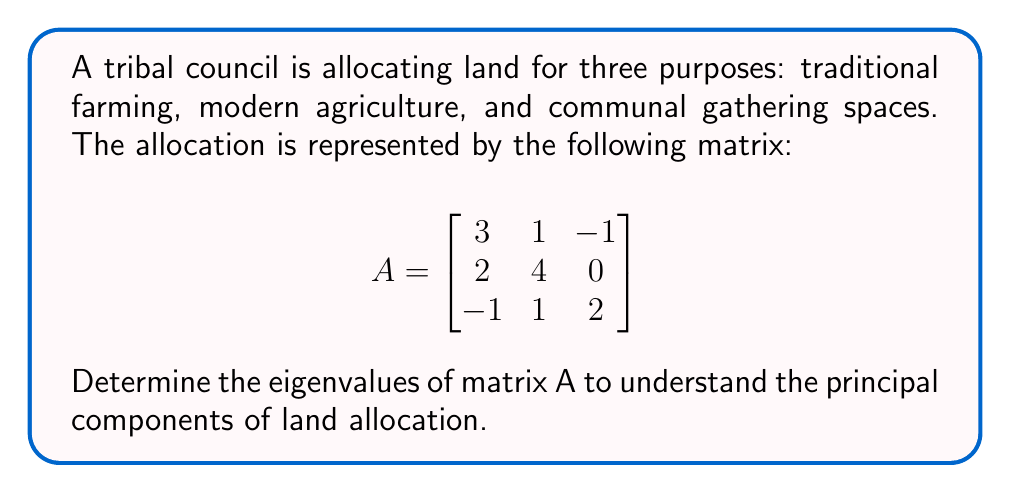Give your solution to this math problem. To find the eigenvalues of matrix A, we follow these steps:

1) The characteristic equation is given by det(A - λI) = 0, where I is the 3x3 identity matrix.

2) Expand det(A - λI):

   $$\begin{vmatrix}
   3-λ & 1 & -1 \\
   2 & 4-λ & 0 \\
   -1 & 1 & 2-λ
   \end{vmatrix} = 0$$

3) Calculate the determinant:
   
   $(3-λ)[(4-λ)(2-λ) - 0] + 1[2(2-λ) - 0] + (-1)[-1(4-λ) - 2] = 0$

4) Simplify:
   
   $(3-λ)(8-6λ+λ^2) + 2(2-λ) + (4-λ+2) = 0$
   
   $(3-λ)(λ^2-6λ+8) + 4-2λ + 6-λ = 0$
   
   $3λ^2-18λ+24 - λ^3+6λ^2-8λ + 10-3λ = 0$
   
   $-λ^3+9λ^2-29λ+34 = 0$

5) Factor the cubic equation:
   
   $-(λ-1)(λ-4)(λ-4) = 0$

6) Solve for λ:
   
   $λ = 1$ or $λ = 4$

Therefore, the eigenvalues are 1 (with algebraic multiplicity 1) and 4 (with algebraic multiplicity 2).
Answer: $λ_1 = 1$, $λ_2 = λ_3 = 4$ 